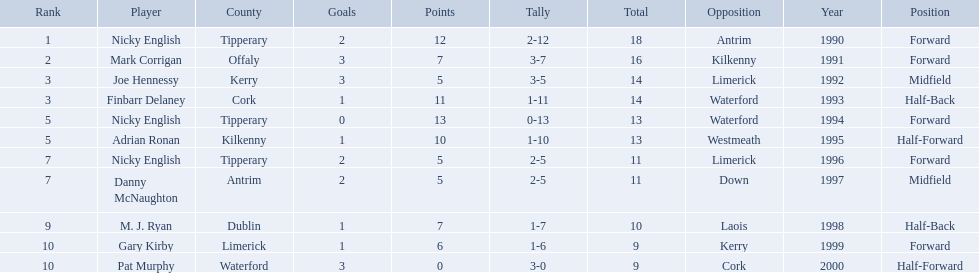Which of the following players were ranked in the bottom 5? Nicky English, Danny McNaughton, M. J. Ryan, Gary Kirby, Pat Murphy. Of these, whose tallies were not 2-5? M. J. Ryan, Gary Kirby, Pat Murphy. From the above three, which one scored more than 9 total points? M. J. Ryan. What numbers are in the total column? 18, 16, 14, 14, 13, 13, 11, 11, 10, 9, 9. What row has the number 10 in the total column? 9, M. J. Ryan, Dublin, 1-7, 10, Laois. What name is in the player column for this row? M. J. Ryan. Who are all the players? Nicky English, Mark Corrigan, Joe Hennessy, Finbarr Delaney, Nicky English, Adrian Ronan, Nicky English, Danny McNaughton, M. J. Ryan, Gary Kirby, Pat Murphy. How many points did they receive? 18, 16, 14, 14, 13, 13, 11, 11, 10, 9, 9. And which player received 10 points? M. J. Ryan. 